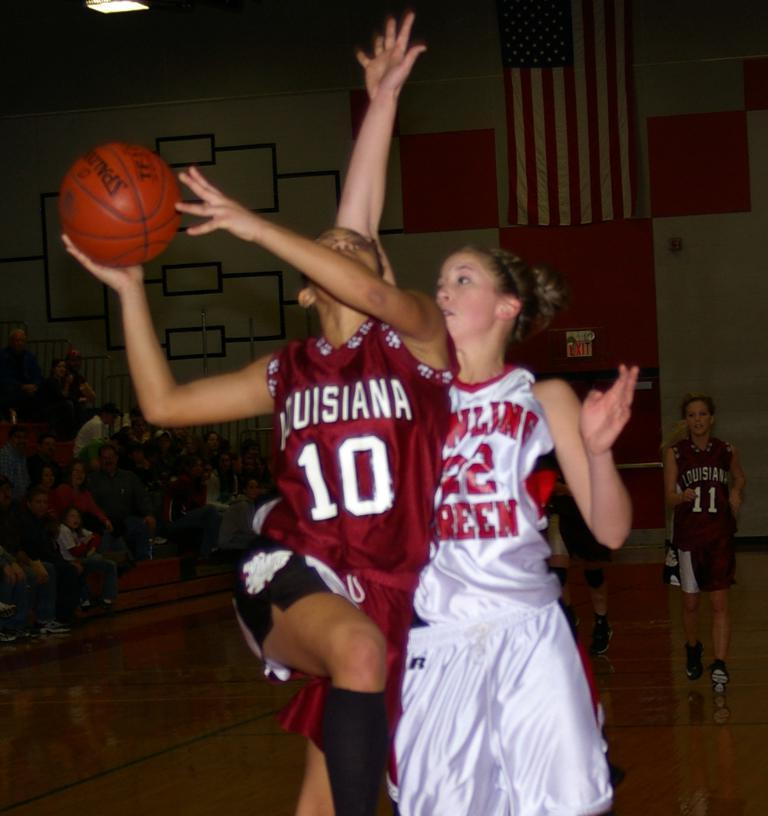<image>
Offer a succinct explanation of the picture presented. A female basketball player from Louisiana makes a shot. 